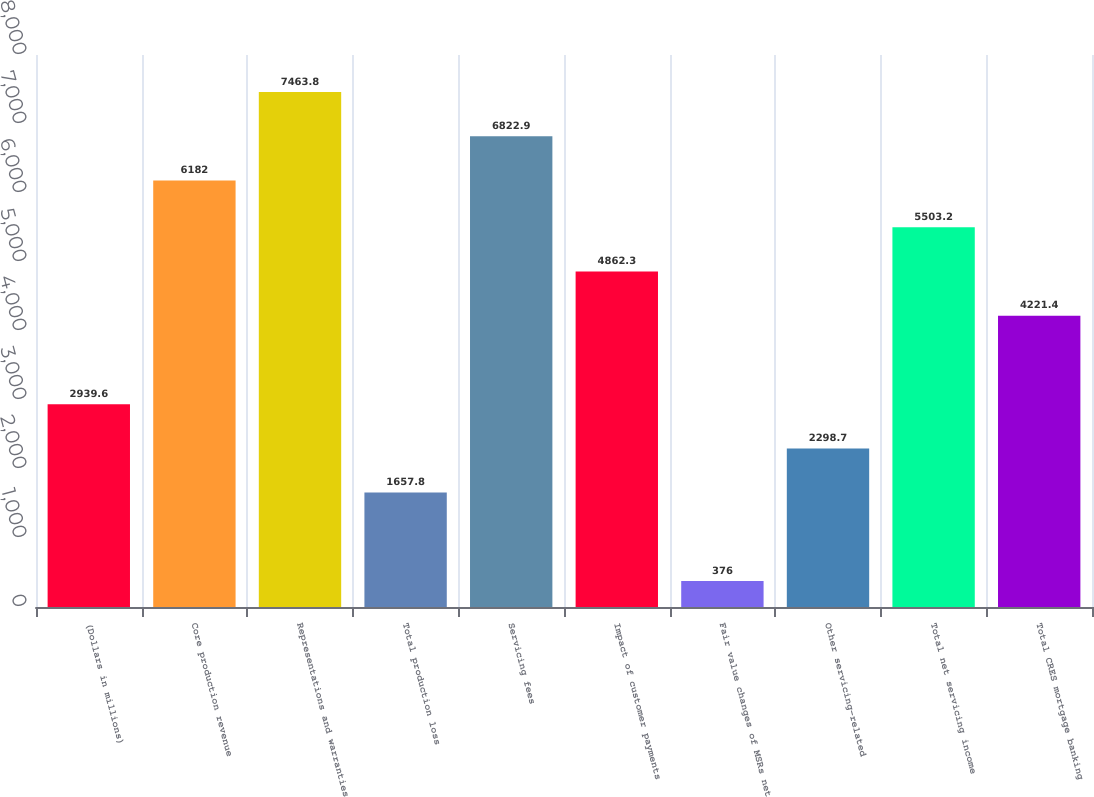Convert chart to OTSL. <chart><loc_0><loc_0><loc_500><loc_500><bar_chart><fcel>(Dollars in millions)<fcel>Core production revenue<fcel>Representations and warranties<fcel>Total production loss<fcel>Servicing fees<fcel>Impact of customer payments<fcel>Fair value changes of MSRs net<fcel>Other servicing-related<fcel>Total net servicing income<fcel>Total CRES mortgage banking<nl><fcel>2939.6<fcel>6182<fcel>7463.8<fcel>1657.8<fcel>6822.9<fcel>4862.3<fcel>376<fcel>2298.7<fcel>5503.2<fcel>4221.4<nl></chart> 